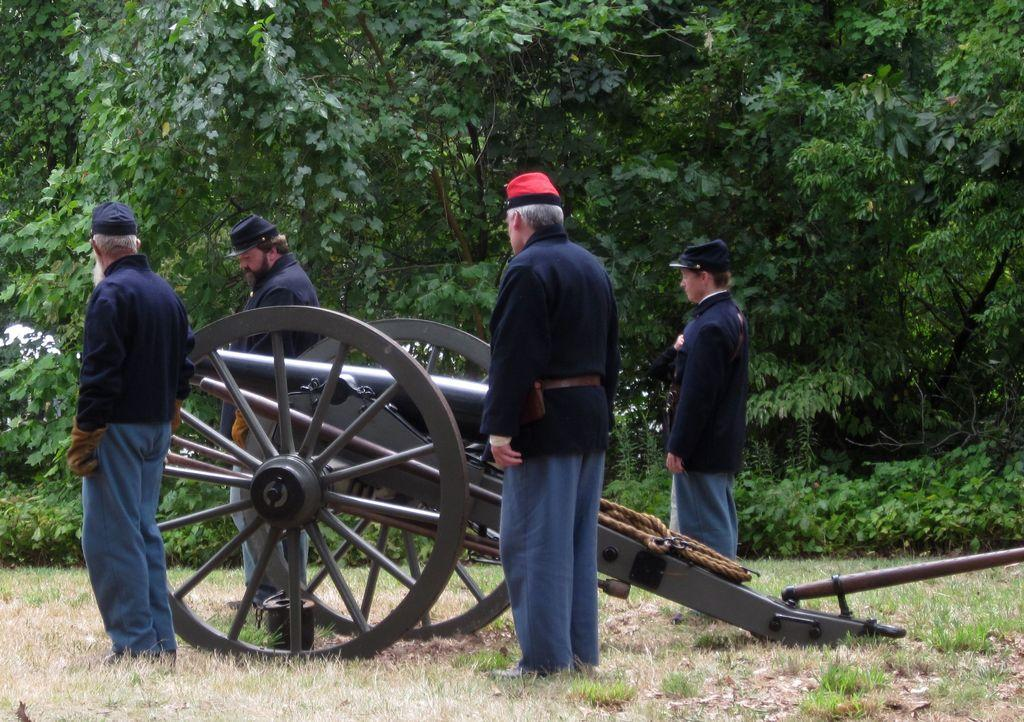What is the main object in the image? There is a cannon in the image. What is the setting of the image? There are people standing on the grass in the image. What can be seen in the background of the image? There are trees in the background of the image. What type of breath can be seen coming from the cannon in the image? There is no breath visible in the image, as cannons do not breathe. 